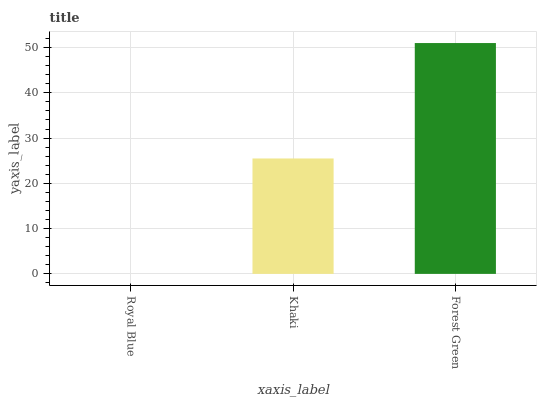Is Royal Blue the minimum?
Answer yes or no. Yes. Is Forest Green the maximum?
Answer yes or no. Yes. Is Khaki the minimum?
Answer yes or no. No. Is Khaki the maximum?
Answer yes or no. No. Is Khaki greater than Royal Blue?
Answer yes or no. Yes. Is Royal Blue less than Khaki?
Answer yes or no. Yes. Is Royal Blue greater than Khaki?
Answer yes or no. No. Is Khaki less than Royal Blue?
Answer yes or no. No. Is Khaki the high median?
Answer yes or no. Yes. Is Khaki the low median?
Answer yes or no. Yes. Is Forest Green the high median?
Answer yes or no. No. Is Royal Blue the low median?
Answer yes or no. No. 